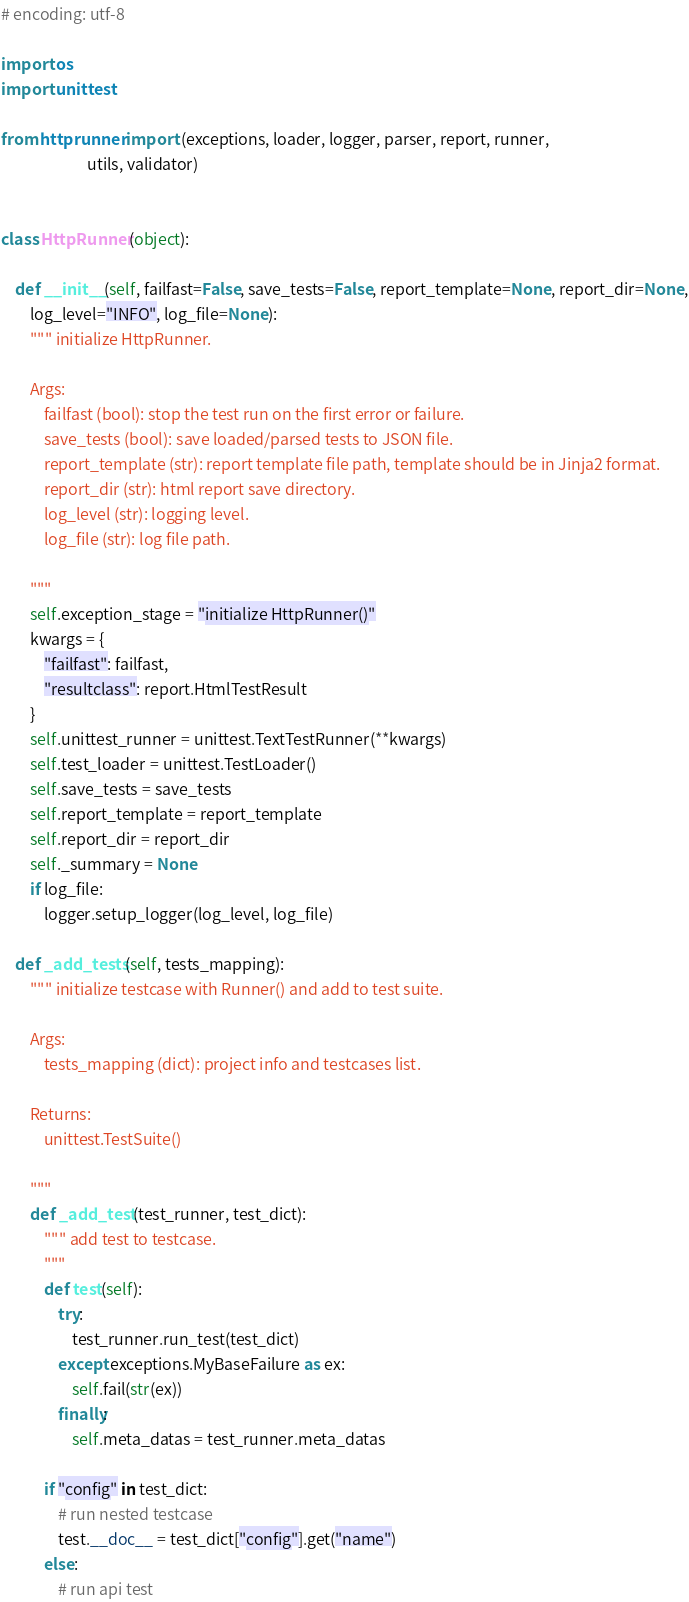Convert code to text. <code><loc_0><loc_0><loc_500><loc_500><_Python_># encoding: utf-8

import os
import unittest

from httprunner import (exceptions, loader, logger, parser, report, runner,
                        utils, validator)


class HttpRunner(object):

    def __init__(self, failfast=False, save_tests=False, report_template=None, report_dir=None,
        log_level="INFO", log_file=None):
        """ initialize HttpRunner.

        Args:
            failfast (bool): stop the test run on the first error or failure.
            save_tests (bool): save loaded/parsed tests to JSON file.
            report_template (str): report template file path, template should be in Jinja2 format.
            report_dir (str): html report save directory.
            log_level (str): logging level.
            log_file (str): log file path.

        """
        self.exception_stage = "initialize HttpRunner()"
        kwargs = {
            "failfast": failfast,
            "resultclass": report.HtmlTestResult
        }
        self.unittest_runner = unittest.TextTestRunner(**kwargs)
        self.test_loader = unittest.TestLoader()
        self.save_tests = save_tests
        self.report_template = report_template
        self.report_dir = report_dir
        self._summary = None
        if log_file:
            logger.setup_logger(log_level, log_file)

    def _add_tests(self, tests_mapping):
        """ initialize testcase with Runner() and add to test suite.

        Args:
            tests_mapping (dict): project info and testcases list.

        Returns:
            unittest.TestSuite()

        """
        def _add_test(test_runner, test_dict):
            """ add test to testcase.
            """
            def test(self):
                try:
                    test_runner.run_test(test_dict)
                except exceptions.MyBaseFailure as ex:
                    self.fail(str(ex))
                finally:
                    self.meta_datas = test_runner.meta_datas

            if "config" in test_dict:
                # run nested testcase
                test.__doc__ = test_dict["config"].get("name")
            else:
                # run api test</code> 